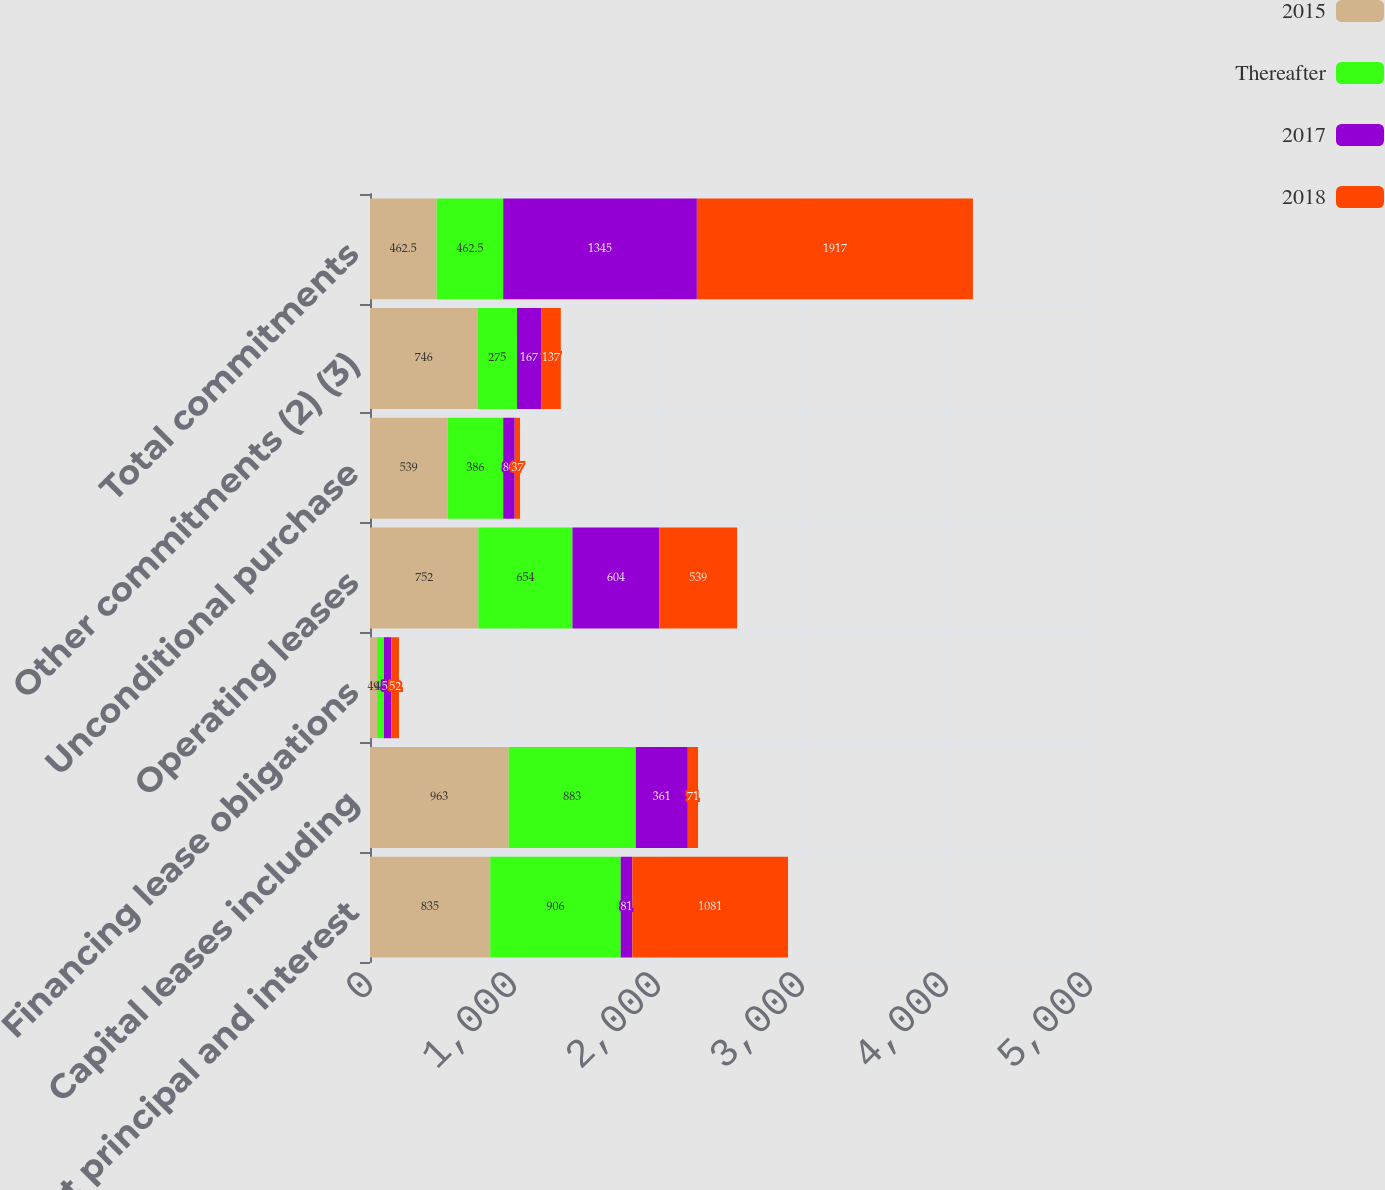<chart> <loc_0><loc_0><loc_500><loc_500><stacked_bar_chart><ecel><fcel>Debt principal and interest<fcel>Capital leases including<fcel>Financing lease obligations<fcel>Operating leases<fcel>Unconditional purchase<fcel>Other commitments (2) (3)<fcel>Total commitments<nl><fcel>2015<fcel>835<fcel>963<fcel>49<fcel>752<fcel>539<fcel>746<fcel>462.5<nl><fcel>Thereafter<fcel>906<fcel>883<fcel>48<fcel>654<fcel>386<fcel>275<fcel>462.5<nl><fcel>2017<fcel>81<fcel>361<fcel>52<fcel>604<fcel>80<fcel>167<fcel>1345<nl><fcel>2018<fcel>1081<fcel>71<fcel>52<fcel>539<fcel>37<fcel>137<fcel>1917<nl></chart> 